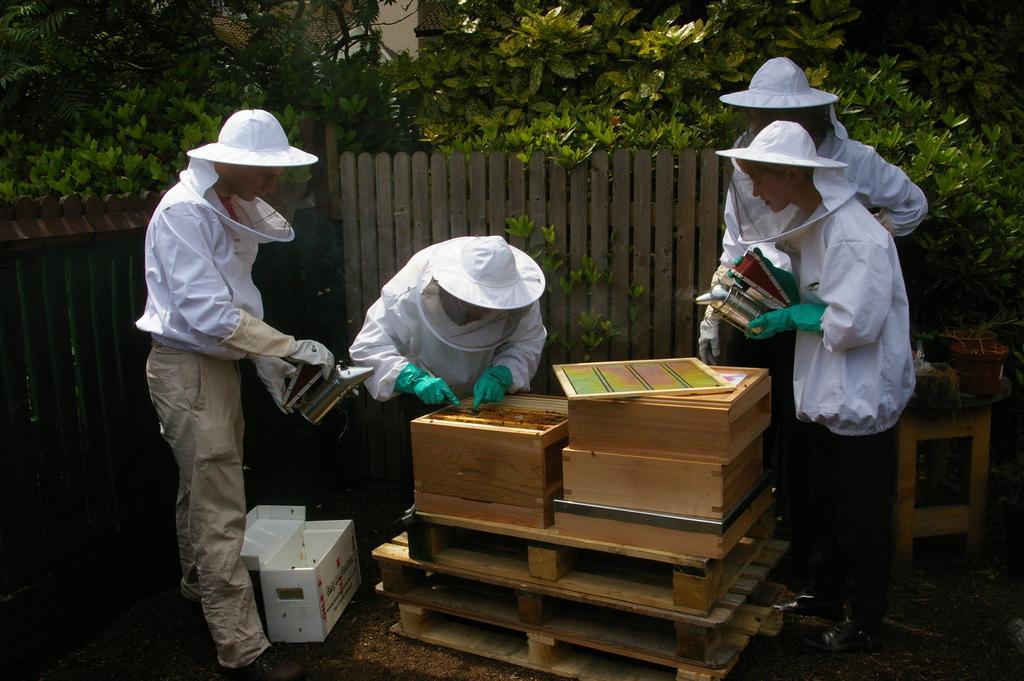Could you give a brief overview of what you see in this image? In this image we can see group of boys wearing white color jackets and net caps, trying to open the honey bee boxes. Behind there is a wooden fencing boards and some plants. 